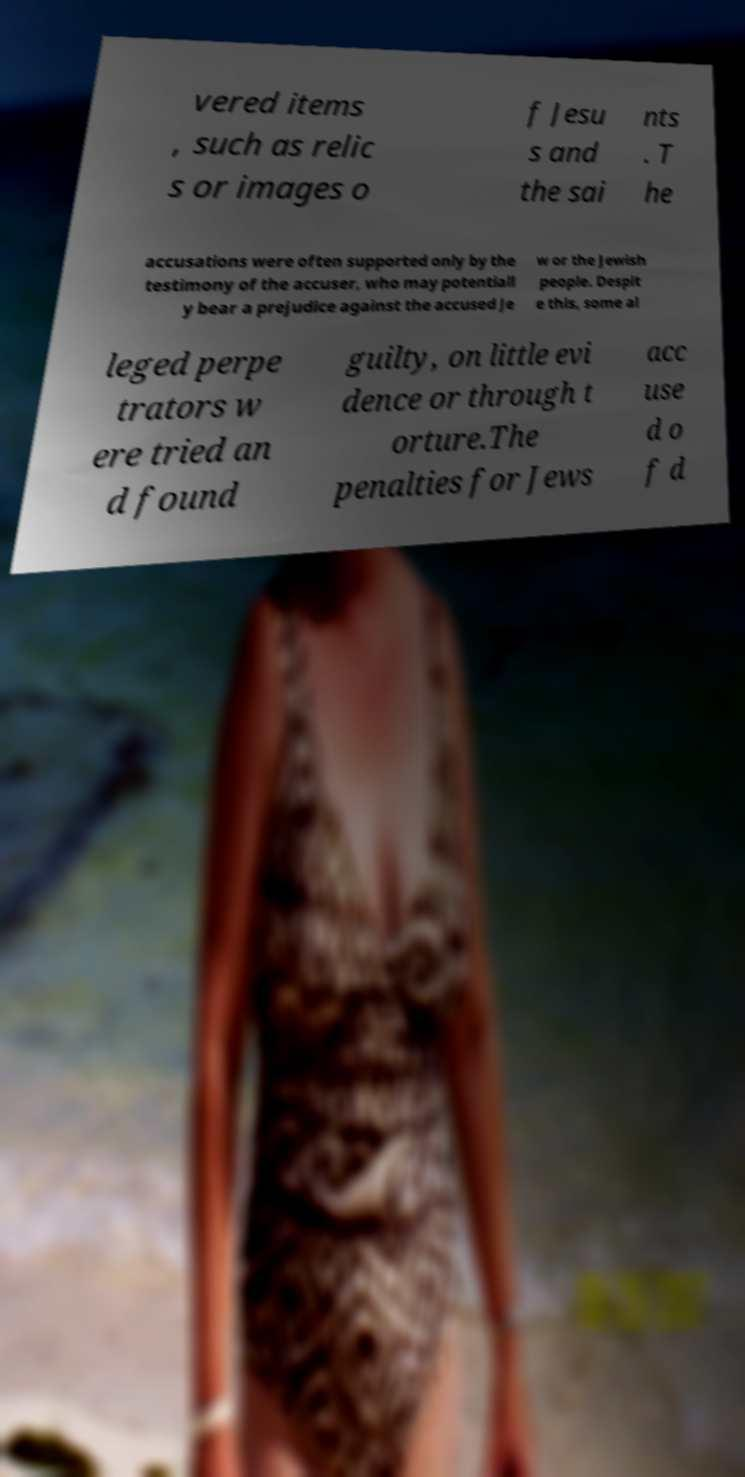What messages or text are displayed in this image? I need them in a readable, typed format. vered items , such as relic s or images o f Jesu s and the sai nts . T he accusations were often supported only by the testimony of the accuser, who may potentiall y bear a prejudice against the accused Je w or the Jewish people. Despit e this, some al leged perpe trators w ere tried an d found guilty, on little evi dence or through t orture.The penalties for Jews acc use d o f d 